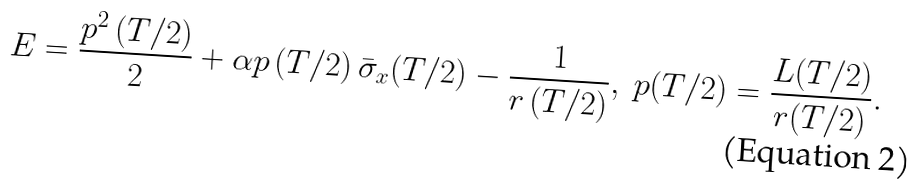Convert formula to latex. <formula><loc_0><loc_0><loc_500><loc_500>E = \frac { p ^ { 2 } \left ( T / 2 \right ) } { 2 } + \alpha p \left ( T / 2 \right ) \bar { \sigma } _ { x } ( T / 2 ) - \frac { 1 } { r \left ( T / 2 \right ) } , \ p ( T / 2 ) = \frac { L ( T / 2 ) } { r ( T / 2 ) } .</formula> 